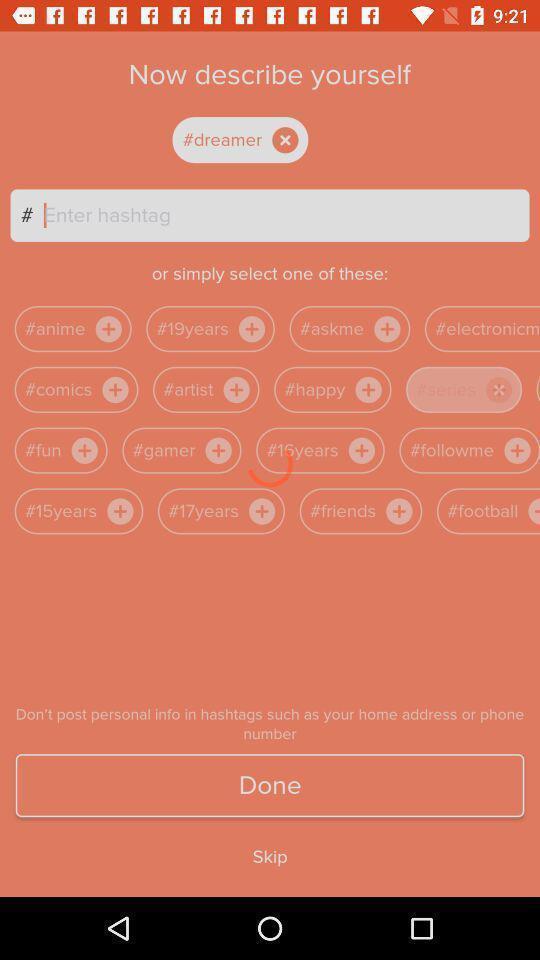Tell me about the visual elements in this screen capture. Text bar in a q a social network app. 